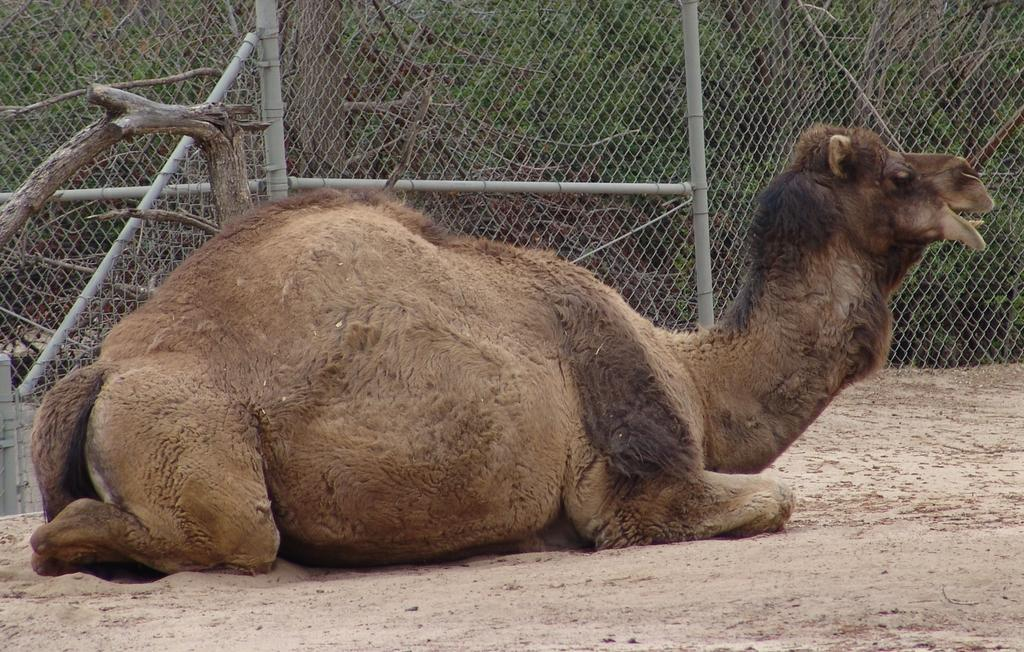What animal is the main subject of the image? There is a camel in the image. What is visible behind the camel? There is mesh visible behind the camel. What type of vegetation can be seen in the image? There are trees visible in the image. What part of the natural environment is visible at the bottom of the image? The land is visible at the bottom of the image. What type of drink is being served in the office in the image? There is no office or drink present in the image; it features a camel and other natural elements. Can you see a door in the image? There is no door visible in the image. 